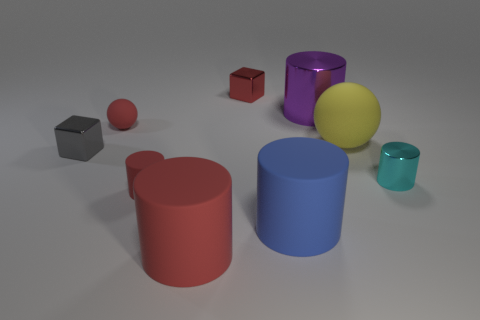Subtract all blue cylinders. How many cylinders are left? 4 Subtract all blue cylinders. How many cylinders are left? 4 Subtract all yellow cylinders. Subtract all brown blocks. How many cylinders are left? 5 Subtract all cubes. How many objects are left? 7 Subtract all small matte objects. Subtract all yellow rubber objects. How many objects are left? 6 Add 1 small matte objects. How many small matte objects are left? 3 Add 7 purple metal cylinders. How many purple metal cylinders exist? 8 Subtract 1 red cylinders. How many objects are left? 8 